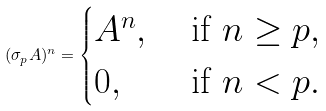<formula> <loc_0><loc_0><loc_500><loc_500>( \sigma _ { p } A ) ^ { n } = \begin{cases} A ^ { n } , & \text { if } n \geq p , \\ 0 , & \text { if } n < p . \end{cases}</formula> 